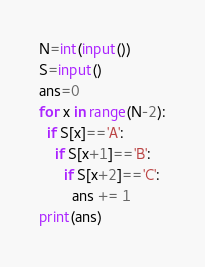Convert code to text. <code><loc_0><loc_0><loc_500><loc_500><_Python_>N=int(input())
S=input()
ans=0
for x in range(N-2):
  if S[x]=='A':
    if S[x+1]=='B':
      if S[x+2]=='C':
        ans += 1
print(ans)</code> 